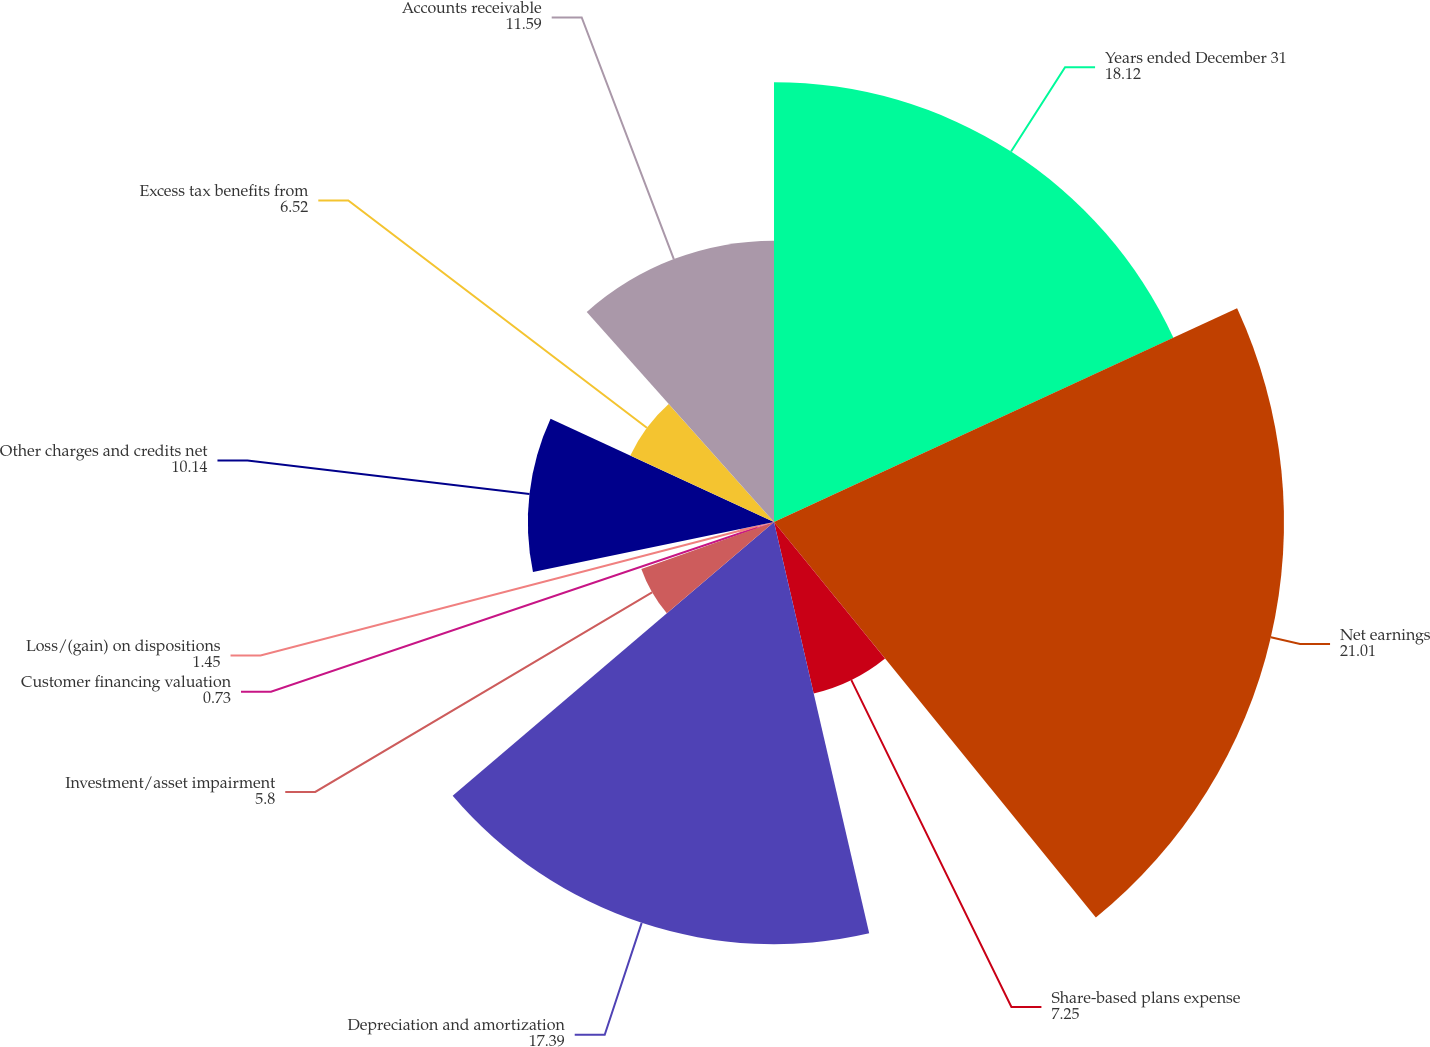Convert chart to OTSL. <chart><loc_0><loc_0><loc_500><loc_500><pie_chart><fcel>Years ended December 31<fcel>Net earnings<fcel>Share-based plans expense<fcel>Depreciation and amortization<fcel>Investment/asset impairment<fcel>Customer financing valuation<fcel>Loss/(gain) on dispositions<fcel>Other charges and credits net<fcel>Excess tax benefits from<fcel>Accounts receivable<nl><fcel>18.12%<fcel>21.01%<fcel>7.25%<fcel>17.39%<fcel>5.8%<fcel>0.73%<fcel>1.45%<fcel>10.14%<fcel>6.52%<fcel>11.59%<nl></chart> 